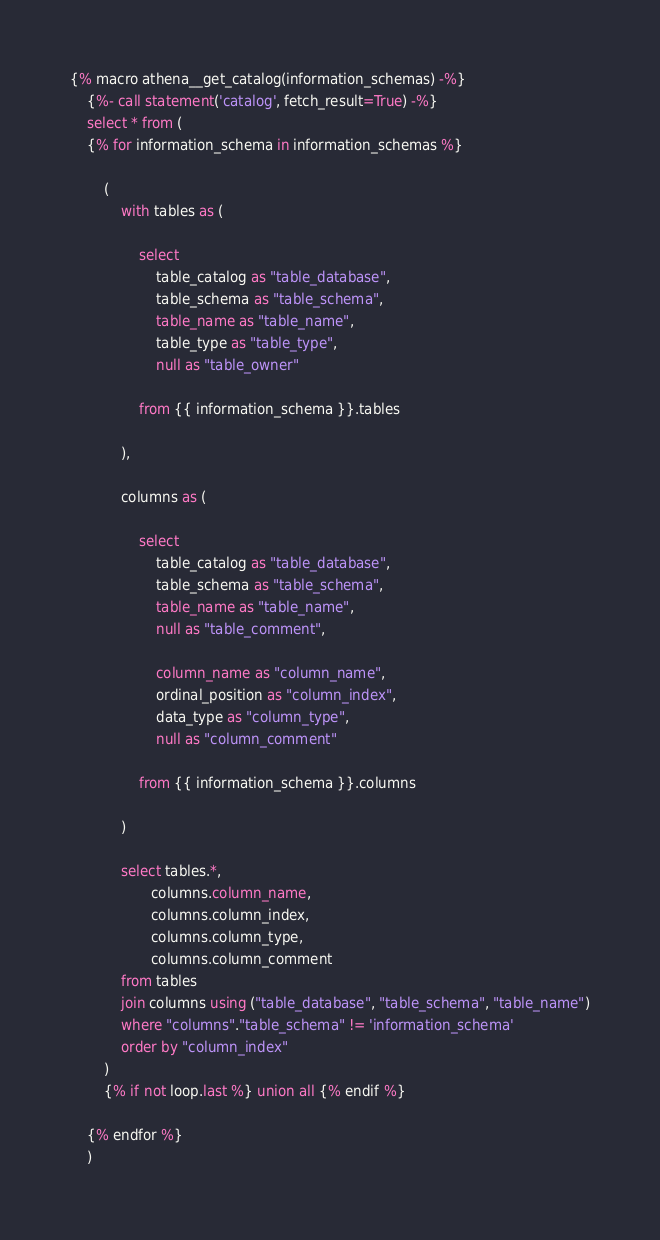Convert code to text. <code><loc_0><loc_0><loc_500><loc_500><_SQL_>
{% macro athena__get_catalog(information_schemas) -%}
    {%- call statement('catalog', fetch_result=True) -%}
    select * from (
    {% for information_schema in information_schemas %}

        (
            with tables as (

                select
                    table_catalog as "table_database",
                    table_schema as "table_schema",
                    table_name as "table_name",
                    table_type as "table_type",
                    null as "table_owner"

                from {{ information_schema }}.tables

            ),

            columns as (

                select
                    table_catalog as "table_database",
                    table_schema as "table_schema",
                    table_name as "table_name",
                    null as "table_comment",

                    column_name as "column_name",
                    ordinal_position as "column_index",
                    data_type as "column_type",
                    null as "column_comment"

                from {{ information_schema }}.columns

            )

            select tables.*,
                   columns.column_name,
                   columns.column_index,
                   columns.column_type,
                   columns.column_comment
            from tables
            join columns using ("table_database", "table_schema", "table_name")
            where "columns"."table_schema" != 'information_schema'
            order by "column_index"
        )
        {% if not loop.last %} union all {% endif %}

    {% endfor %}
    )</code> 